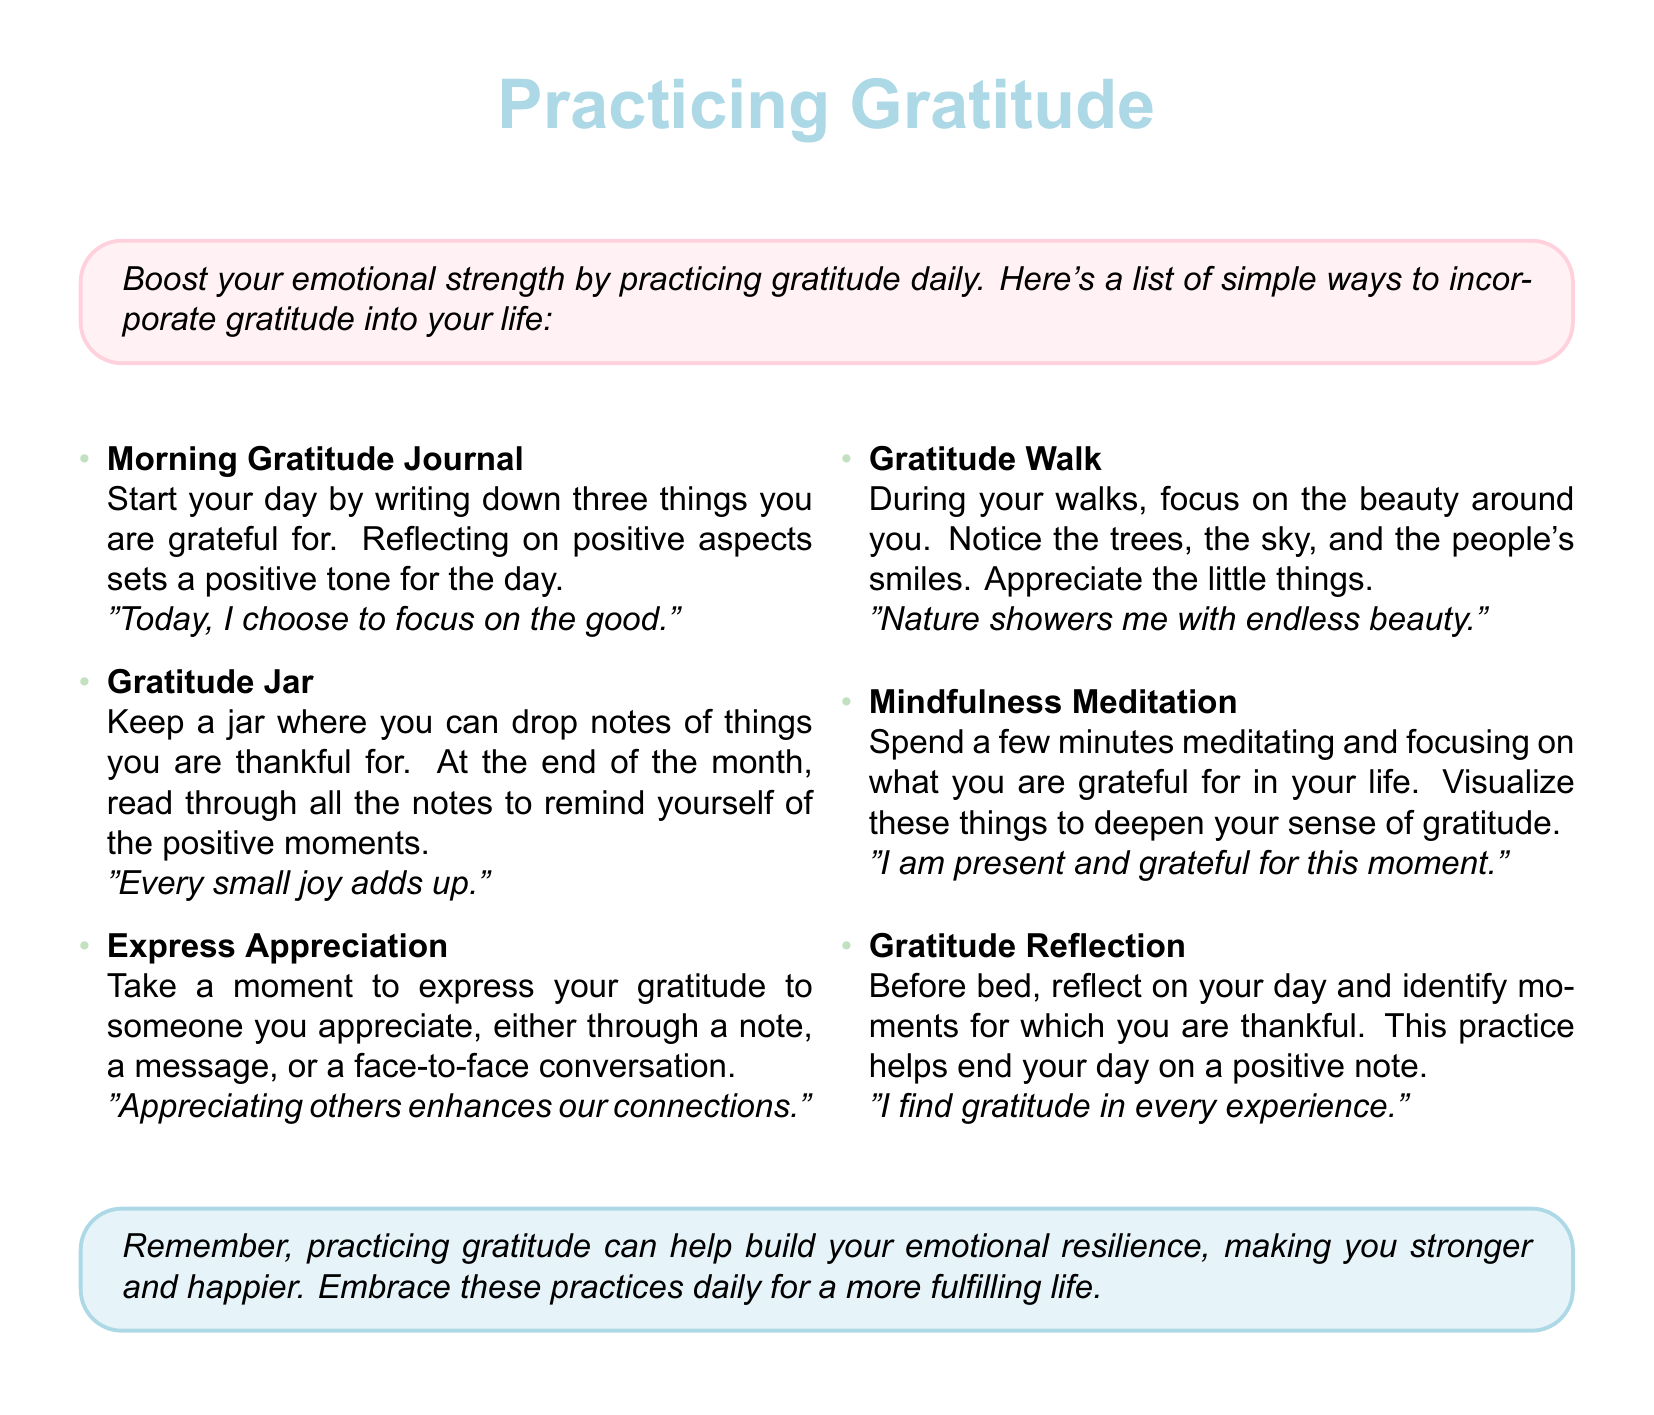What is the title of the card? The title of the card is prominently displayed in the center, indicating the main theme of gratitude.
Answer: Practicing Gratitude How many simple ways to practice gratitude are listed? The document contains a list that is explicitly numbered, making it easy to determine the count.
Answer: Six What color is used for the background of the gratitude box? The color used for the background of the gratitude box is specified in the document.
Answer: Pastel pink Which gratitude practice encourages reflection at the end of the day? The relevant method is described in the section, highlighting its focus on gratitude before sleeping.
Answer: Gratitude Reflection What phrase is encouraged during mindfulness meditation? A specific phrase is provided in association with the mindfulness meditation practice for focusing on gratitude.
Answer: I am present and grateful for this moment What does the gratitude jar help with? The purpose of this practice is outlined in the document, relating to remembering positive moments.
Answer: Remind yourself of the positive moments What is one way to express gratitude mentioned in the document? One method detailed in the card involves direct communication with someone appreciated.
Answer: Face-to-face conversation 